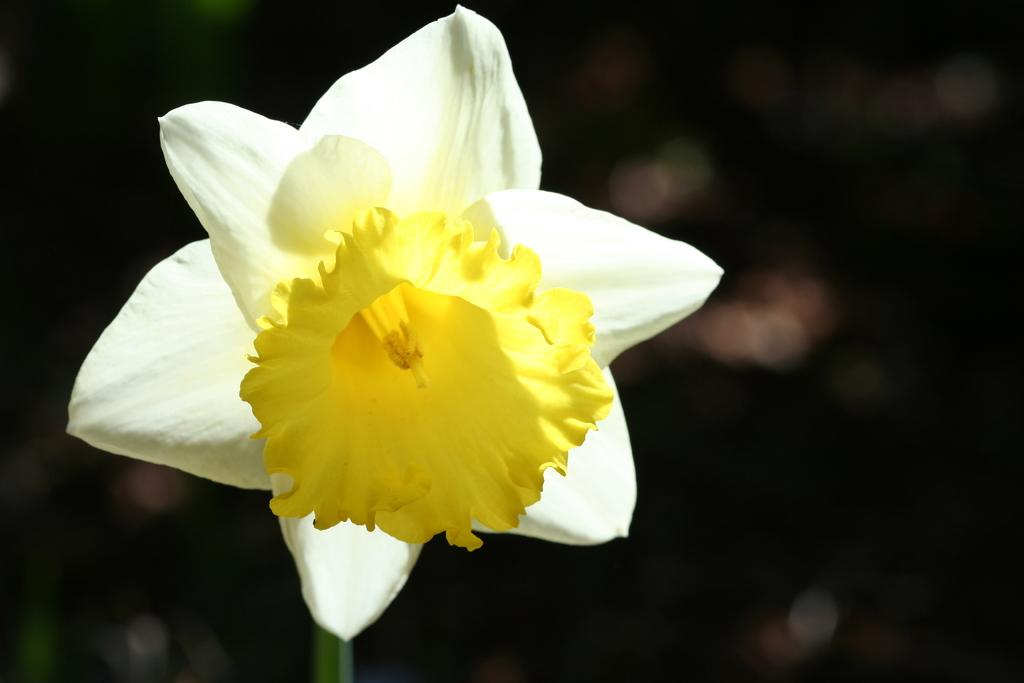What type of flower is in the picture? There is a white and yellow flower in the picture. Can you describe the background of the picture? The backdrop is blurred. What type of airplane is visible in the picture? There is no airplane present in the picture; it features a white and yellow flower with a blurred backdrop. How does the chicken grip the flower in the picture? There is no chicken present in the picture, and therefore no such interaction can be observed. 